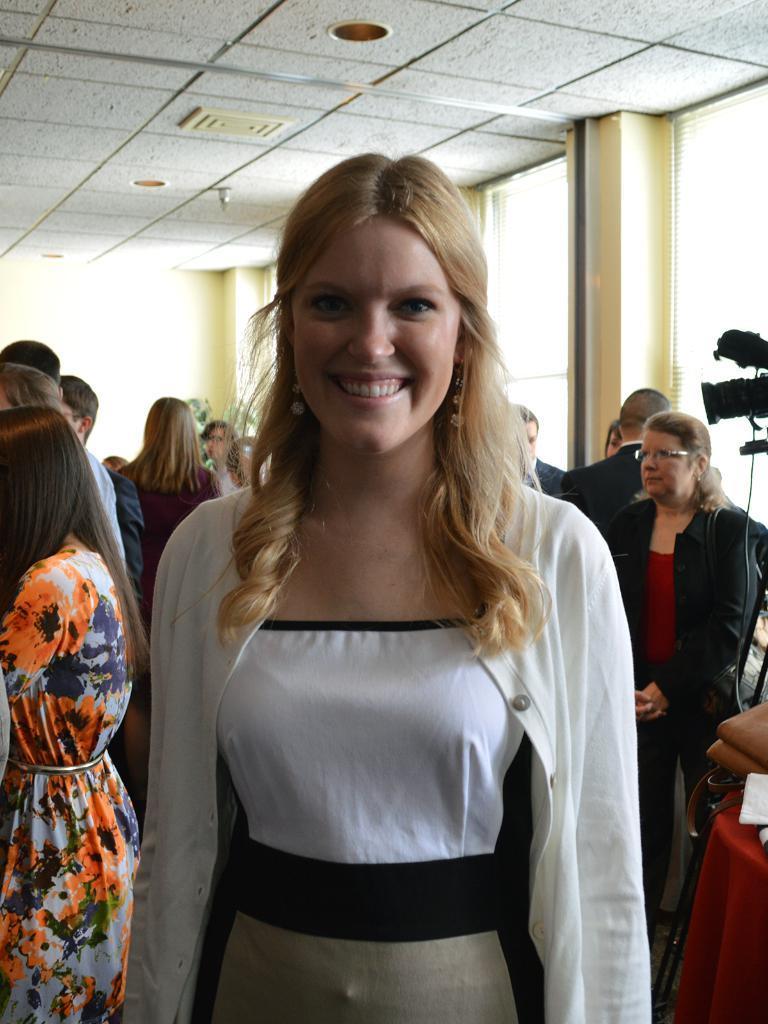Could you give a brief overview of what you see in this image? In this picture there are people standing, among them there is a woman standing and smiling. In the background of the image we can see wall and glass. At the top of the image we can see ceiling and lights. On the right side of the image we can see camera, bag and objects on the table. 